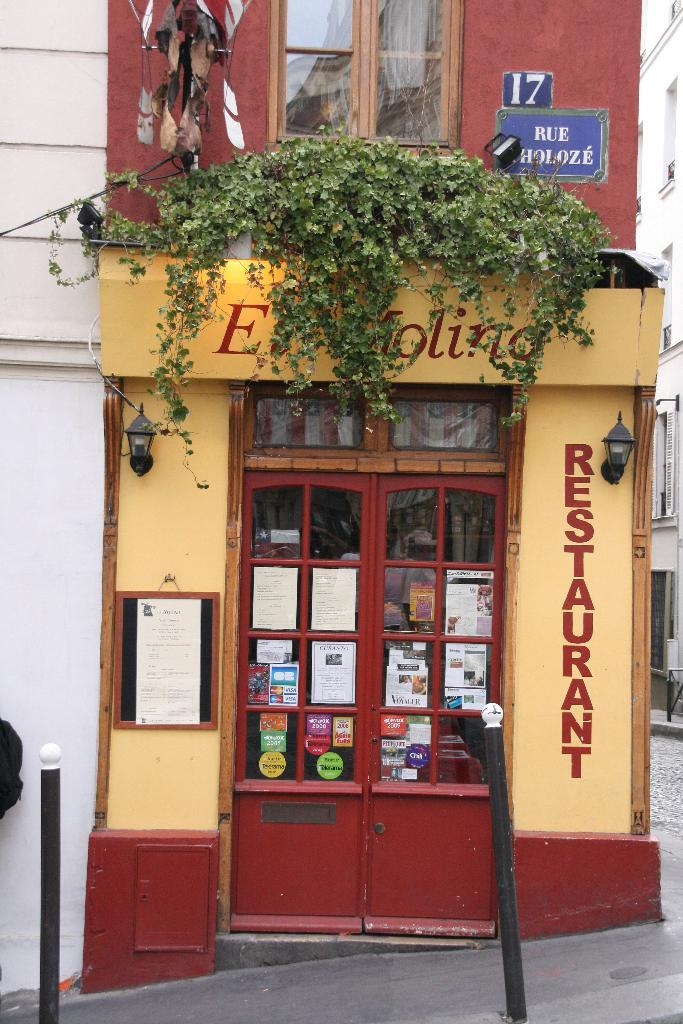What objects can be seen in the image that resemble poles? There are small poles in the image. What type of structure is present in the image? There is a stall in the image. What type of vegetation is visible in the foreground of the image? It appears that there is a creeper in the foreground area of the image. What can be seen in the background of the image? There is a building in the background of the image. What holiday is being celebrated in the image? There is no indication of a holiday being celebrated in the image. How many sons are present in the image? There is no mention of any sons in the image. 